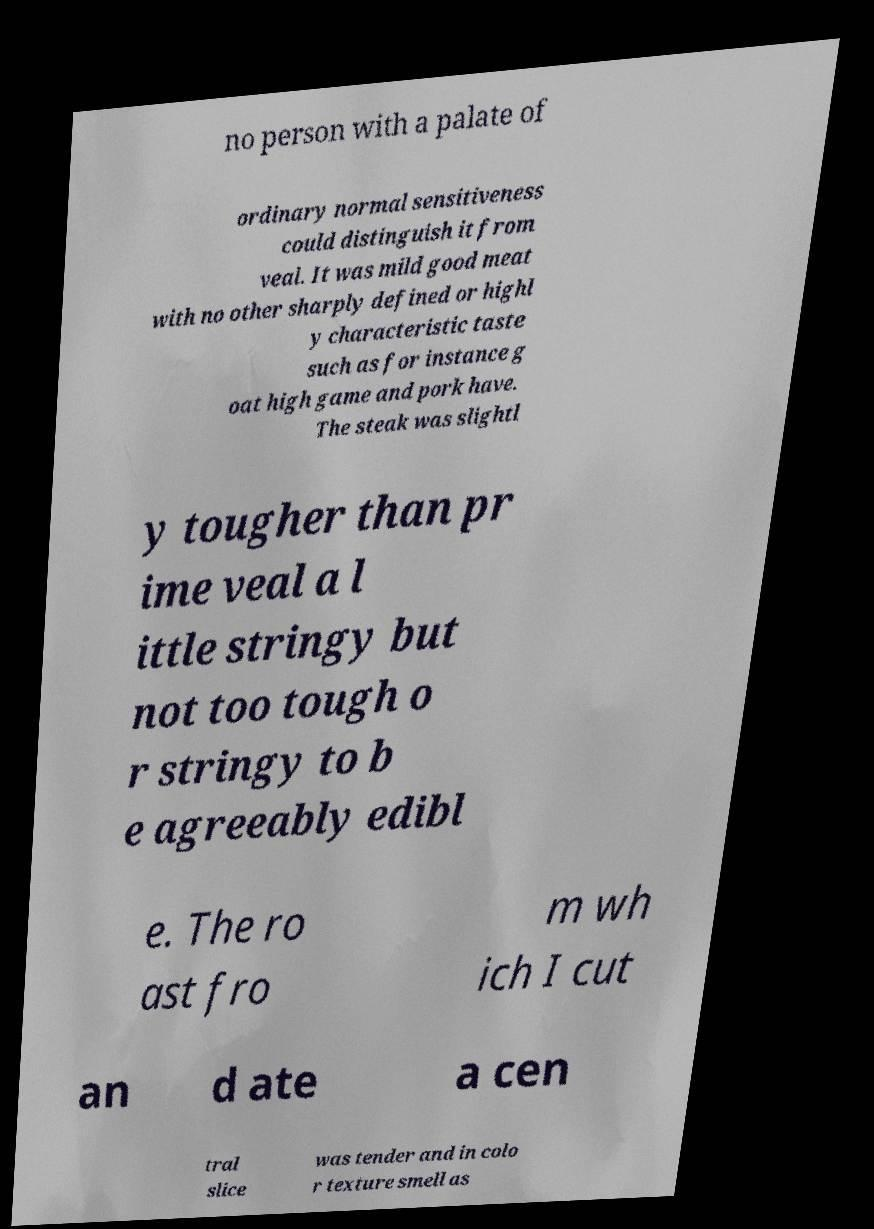There's text embedded in this image that I need extracted. Can you transcribe it verbatim? no person with a palate of ordinary normal sensitiveness could distinguish it from veal. It was mild good meat with no other sharply defined or highl y characteristic taste such as for instance g oat high game and pork have. The steak was slightl y tougher than pr ime veal a l ittle stringy but not too tough o r stringy to b e agreeably edibl e. The ro ast fro m wh ich I cut an d ate a cen tral slice was tender and in colo r texture smell as 